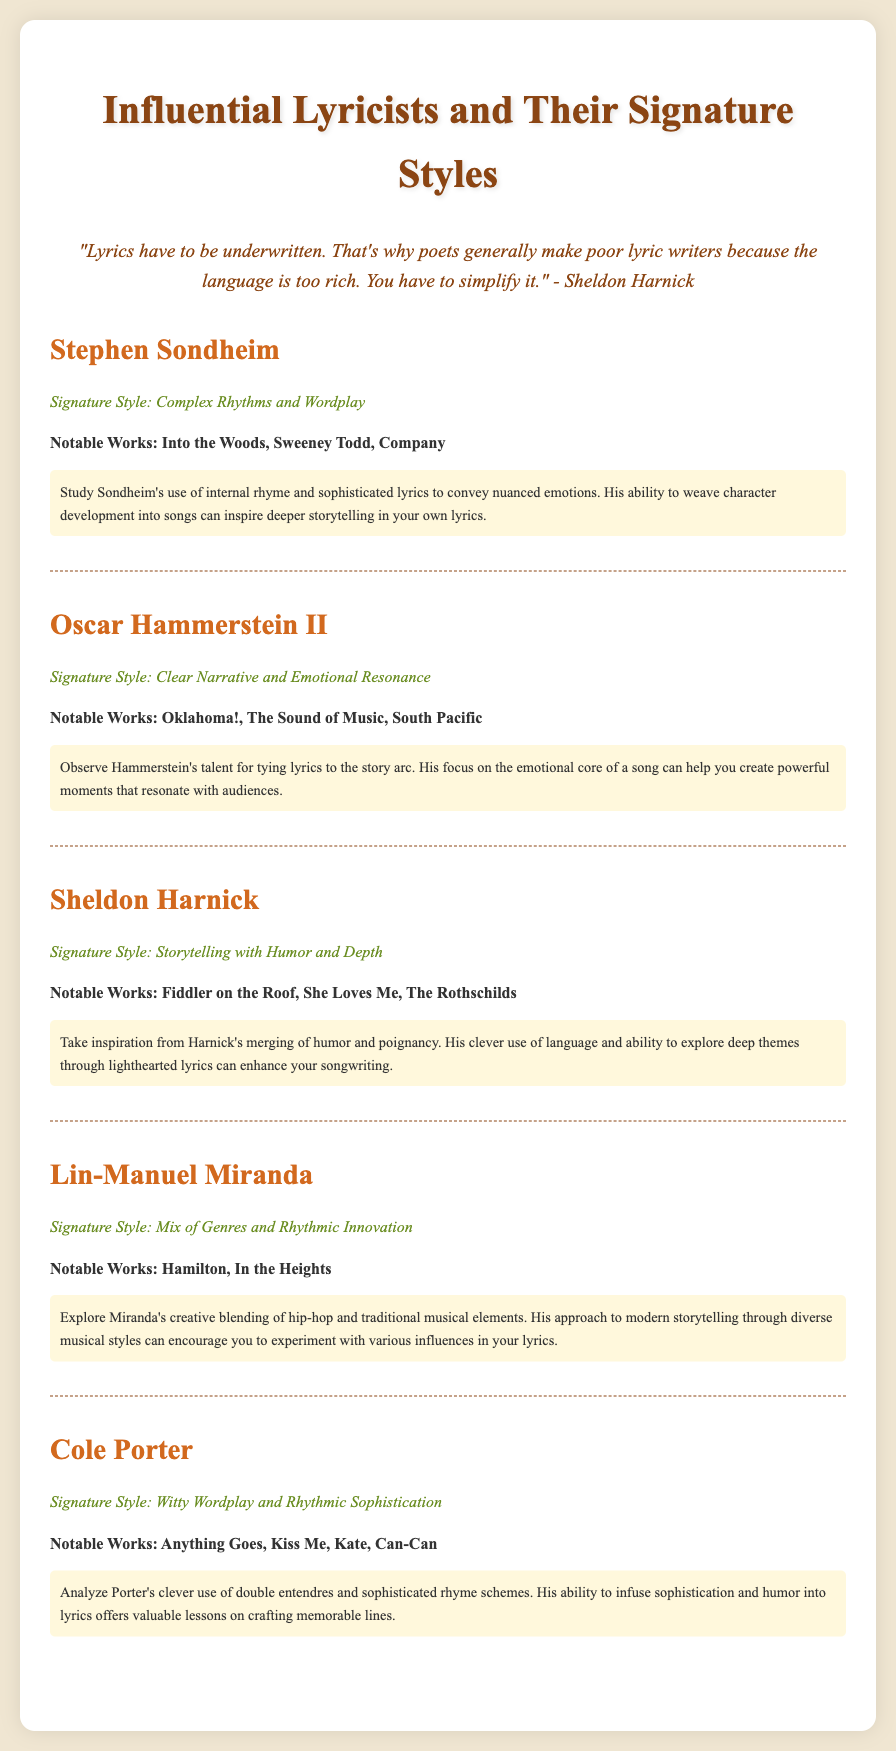What is the signature style of Stephen Sondheim? The signature style for Stephen Sondheim is described in the document as "Complex Rhythms and Wordplay."
Answer: Complex Rhythms and Wordplay Which notable work is associated with Oscar Hammerstein II? The document lists "Oklahoma!" as one of the notable works of Oscar Hammerstein II.
Answer: Oklahoma! What can you learn from Sheldon Harnick's work? The learning notes for Sheldon Harnick provide insights on how to "merge humor and poignancy."
Answer: Merge humor and poignancy Who is known for the musical "Hamilton"? The document identifies Lin-Manuel Miranda as the lyricist known for "Hamilton."
Answer: Lin-Manuel Miranda What is the common theme in Cole Porter's writing style? The document mentions Cole Porter's writing style as focusing on "Witty Wordplay and Rhythmic Sophistication."
Answer: Witty Wordplay and Rhythmic Sophistication How many lyricists are featured in the document? The document outlines five influential lyricists.
Answer: Five What notable work is attributed to Lin-Manuel Miranda? Among the notable works attributed to Lin-Manuel Miranda, "In the Heights" is mentioned in the document.
Answer: In the Heights What aspect of songwriting does Oscar Hammerstein II emphasize? The learning notes suggest that Oscar Hammerstein II emphasizes "tying lyrics to the story arc."
Answer: Tying lyrics to the story arc What unique element does Lin-Manuel Miranda incorporate into his lyrics? The document highlights that Lin-Manuel Miranda incorporates "a mix of genres and rhythmic innovation" in his lyrics.
Answer: Mix of genres and rhythmic innovation 